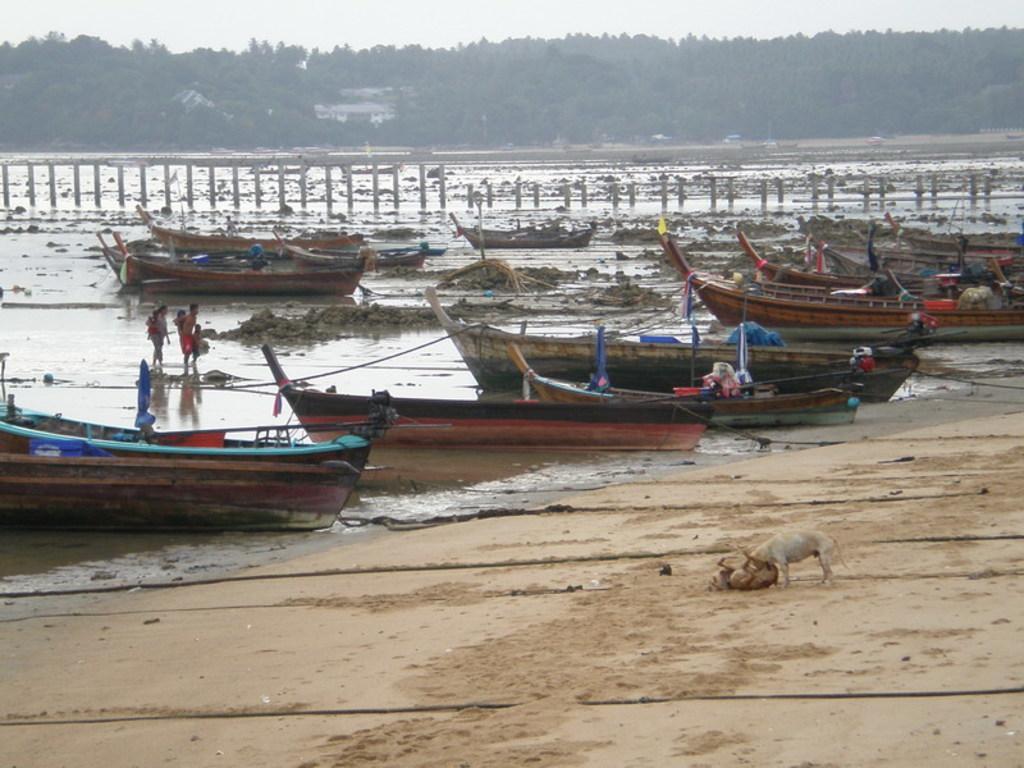Please provide a concise description of this image. In this image we can see a lake. There are few persons at the left side of the image. There are barriers in the image. There are many water crafts in the image. There are many trees in the image. There are few houses in the image. There are two dogs in the image. We can see the sky in the image. 